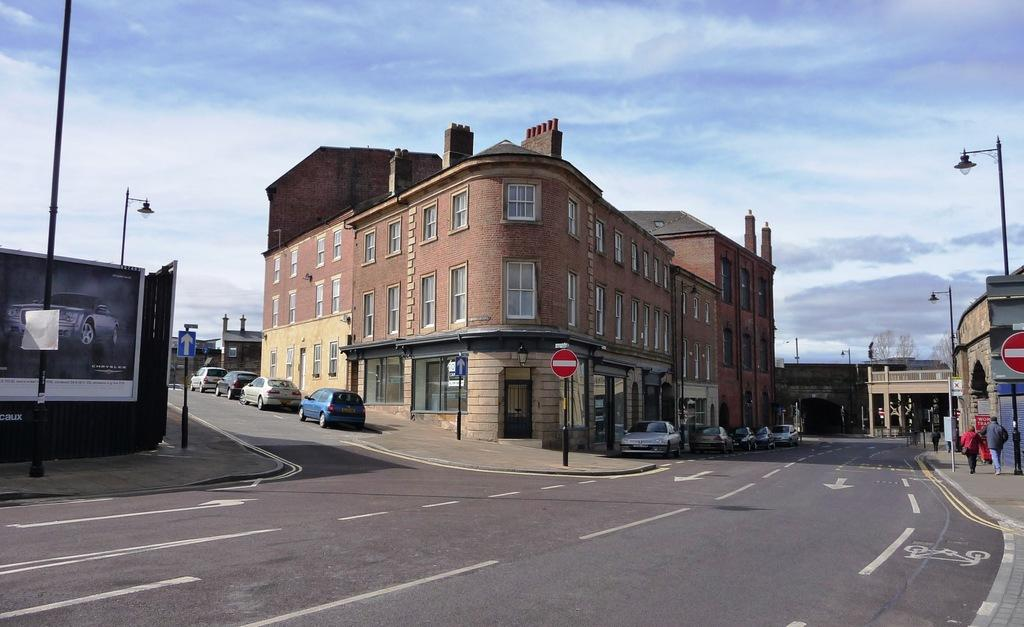What can be seen on the road in the image? There are cars on the road in the image. What is visible on either side of the road? There are buildings on either side of the road. What verse is being recited by the person in the image? There is no person visible in the image, and therefore no verse being recited. How many thumbs can be seen on the person in the image? There is no person visible in the image, and therefore no thumbs can be seen. 